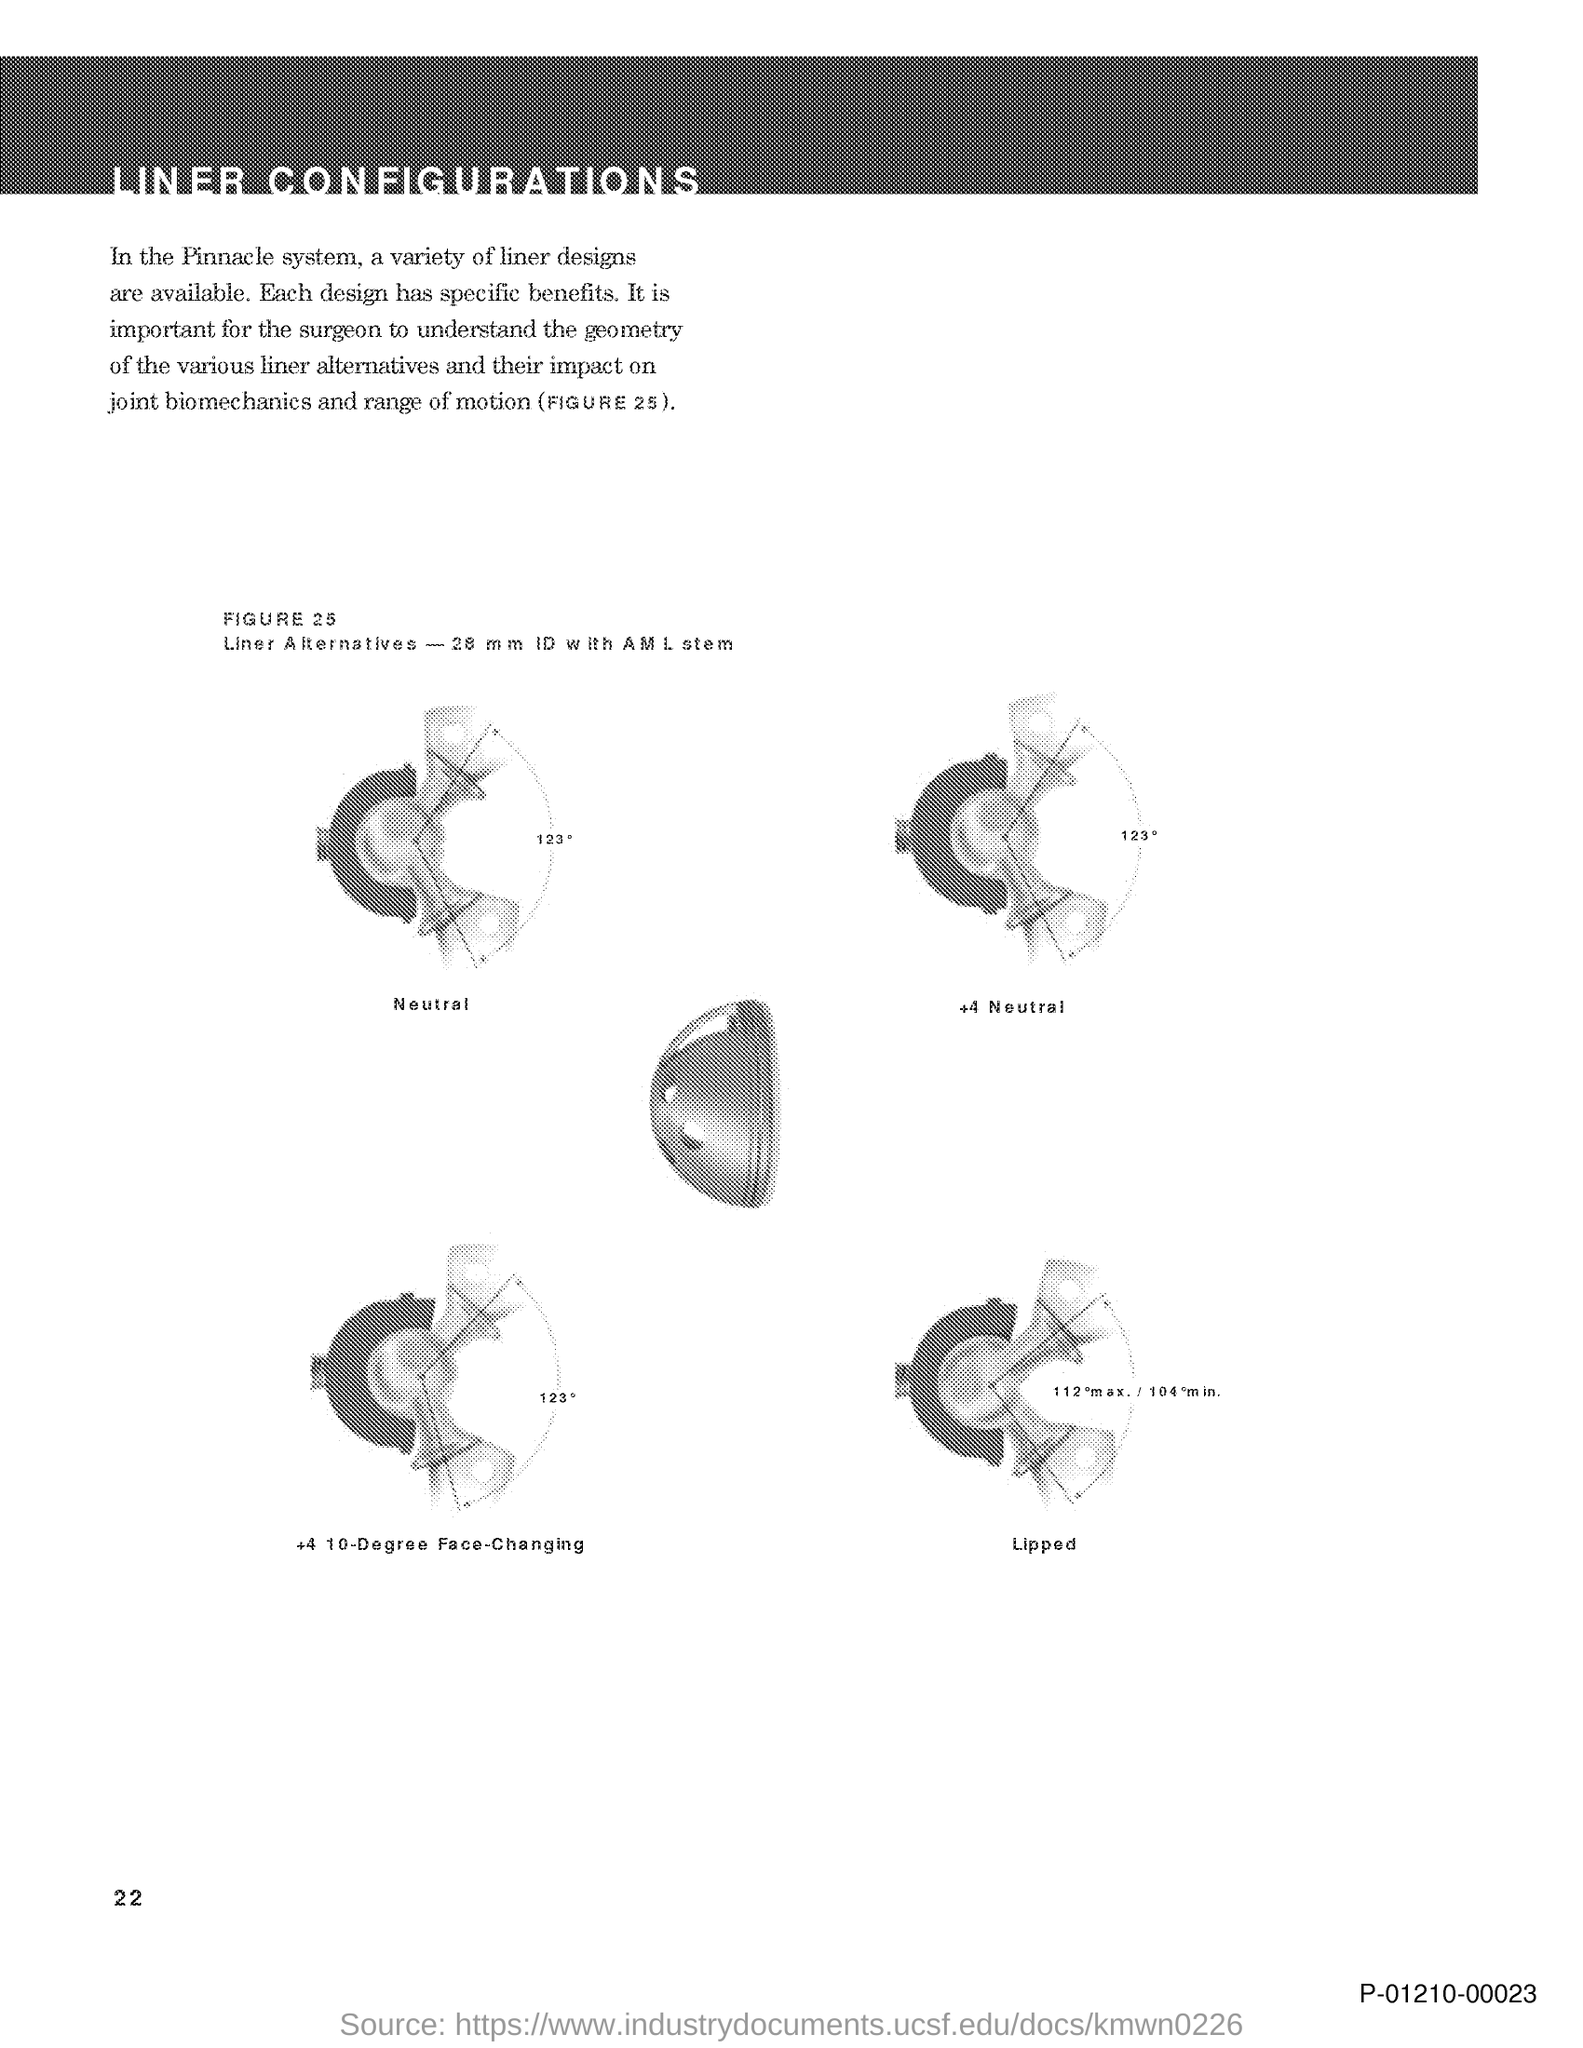What is the document title?
Ensure brevity in your answer.  LINER CONFIGURATIONS. What is the page number on this document?
Give a very brief answer. 22. What is the code at the bottom right corner of the page?
Offer a terse response. P-01210-00023. 